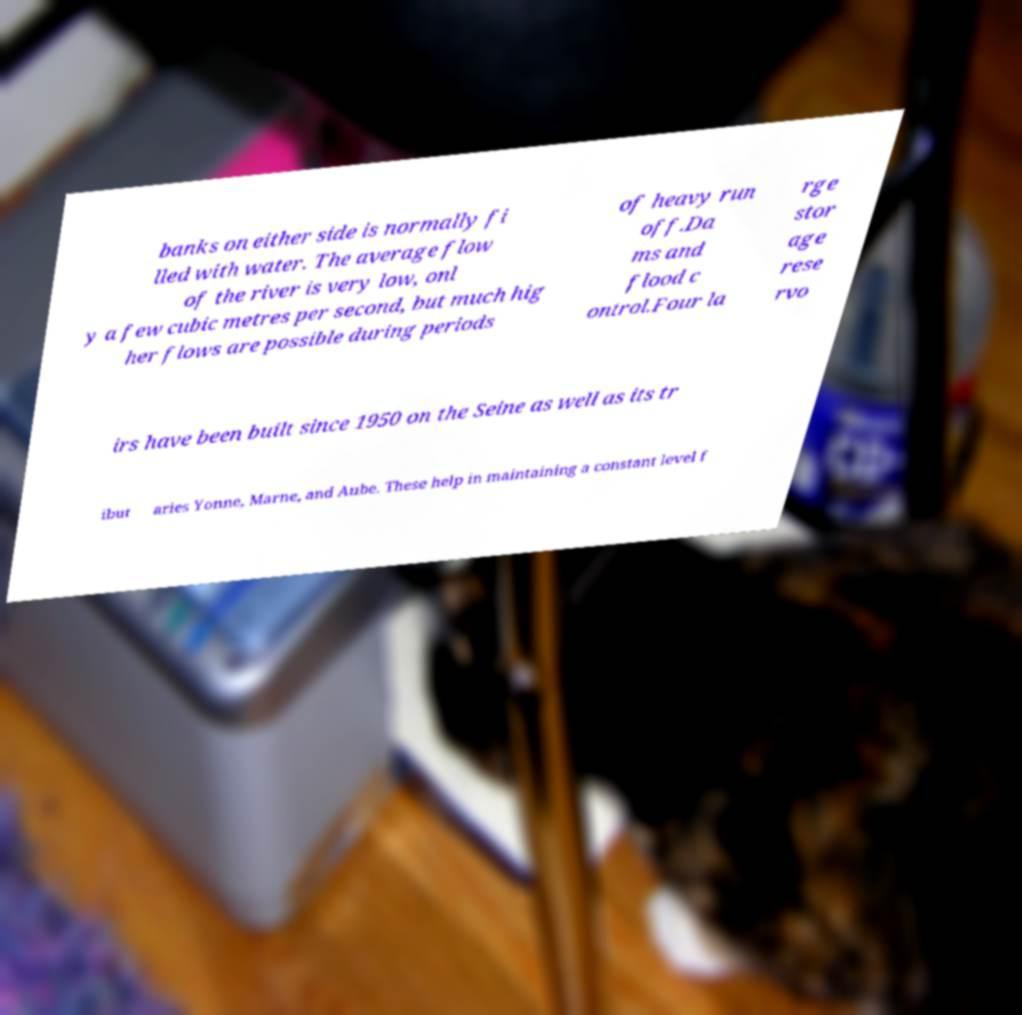Can you accurately transcribe the text from the provided image for me? banks on either side is normally fi lled with water. The average flow of the river is very low, onl y a few cubic metres per second, but much hig her flows are possible during periods of heavy run off.Da ms and flood c ontrol.Four la rge stor age rese rvo irs have been built since 1950 on the Seine as well as its tr ibut aries Yonne, Marne, and Aube. These help in maintaining a constant level f 